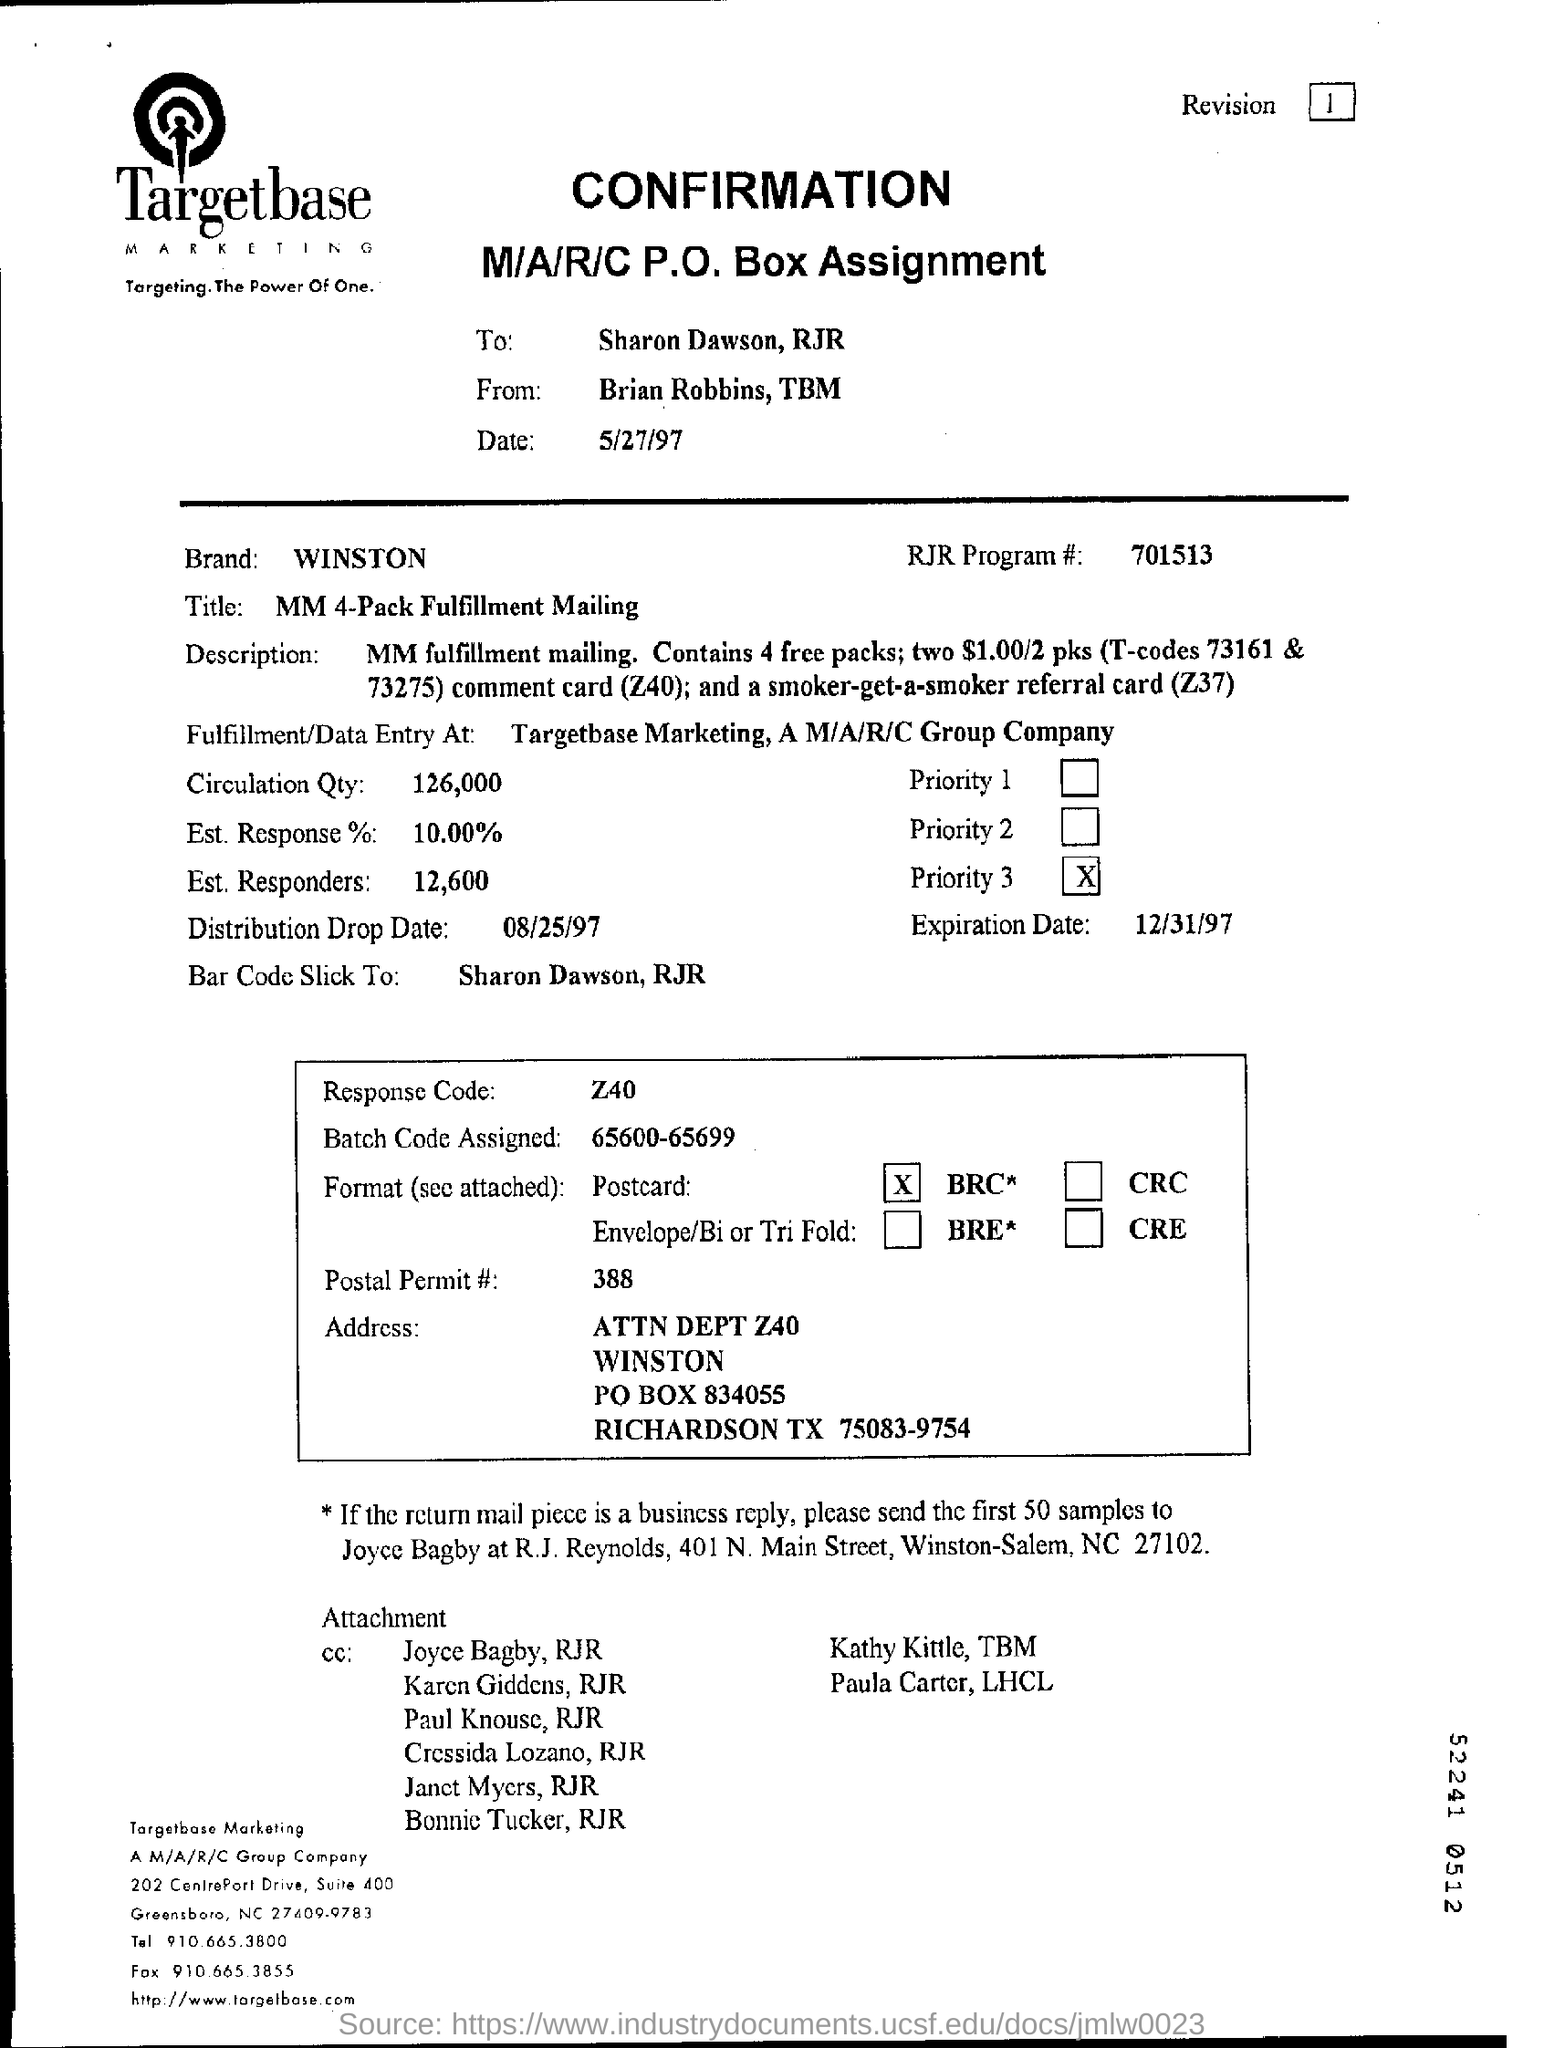Who sent this ?
Your response must be concise. Brain robbins , tbm. Who is the recipient ?
Offer a terse response. Sharon Dawson, RJR. What is the date mentioned in the top of the document ?
Your response must be concise. 5/27/97. What is the Brand Name ?
Offer a terse response. WINSTON. What is the RJR Program Number ?
Provide a short and direct response. 701513. What is the Expiration Date ?
Provide a succinct answer. 12/31/97. What is the P.O Box Number ?
Your response must be concise. 834055. What is the Distribution Drop Date ?
Your answer should be very brief. 08/25/97. What is the Postal Permit Number ?
Offer a very short reply. 388. What is Response Code Number ?
Make the answer very short. Z40. 